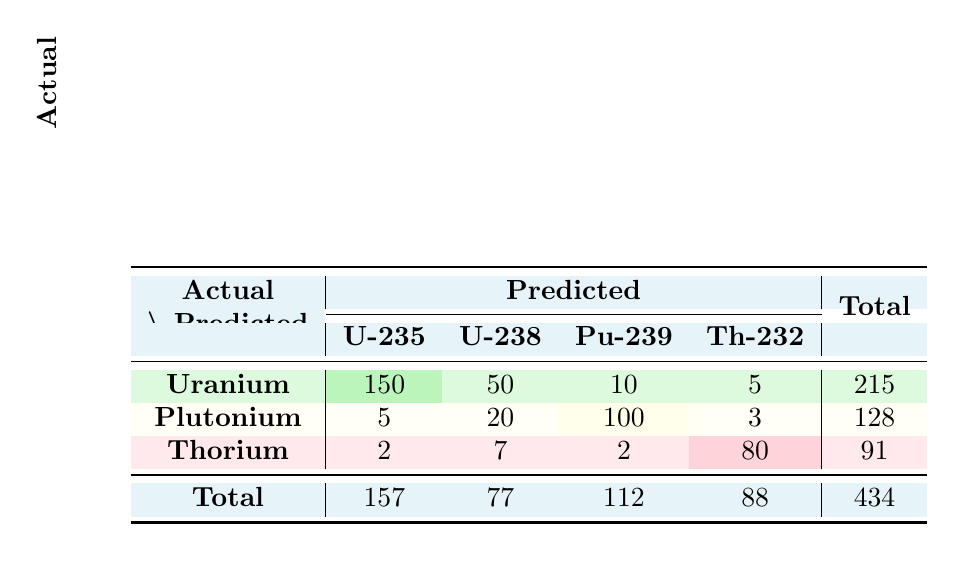What is the total number of predicted plutonium-239 classified as plutonium? In the "Predicted" row for "Plutonium", the value for Pu-239 is 100. Thus, the total predicted plutonium-239 classified as plutonium is simply taken directly from this cell in the table.
Answer: 100 What is the total amount of uranium-238 in the actual assessment? To find the total amount of U-238 in the actual assessment, we sum the values in all three actual material categories for U-238: Uranium (50) + Plutonium (20) + Thorium (7), resulting in 50 + 20 + 7 = 77.
Answer: 77 Does the actual assessment have more thorium-232 than predicted? The actual assessment value for Th-232 is 80, while the predicted value is 70. Since 80 is greater than 70, the statement is true.
Answer: Yes What is the overall accuracy of the classification for uranium-235? To calculate the accuracy for U-235, we take the correctly predicted value (150) and divide it by the total actual value (215). This gives us 150/215 which approximates to 0.698 or 69.8%.
Answer: Approximately 69.8% How many total misclassifications were made for uranium-238? The misclassifications for U-238 can be calculated by adding the predictions made for U-238 from other actual categories: Uranium-235 (10) + Plutonium (5) + Thorium (5), which totals 10 + 5 + 5 = 20.
Answer: 20 What is the total number of mistakenly classified material types in the entire table? To find the total misclassified materials, we need to sum all off-diagonal predictions: (10 for U-235, 5 for U-238, 15 for Pu-239, 5 for Th-232 in Uranium; 5 for U-235, 20 for U-238, 3 for Th-232 in Plutonium; 2 for U-235, 7 for U-238, 2 for Pu-239 in Thorium). Total misclassifications come to 10 + 5 + 15 + 5 + 5 + 20 + 3 + 2 + 7 + 2 = 74.
Answer: 74 What percentage of the total predictions were correctly classified for thorium-232? The actual assessment for Th-232 is 80, and it was predicted as 70. To calculate the percentage of correctly classified: correct prediction/(total actual) x 100 = 70/91 x 100, resulting in approximately 76.9%.
Answer: Approximately 76.9% Which material type had the highest number of misclassifications? The misclassifications can be evaluated by analyzing the off-diagonal values; U-238 has a total of 20 misclassifications from other materials. In comparison, if these numbers are calculated for each material, U-238 shows the highest miss.
Answer: U-238 